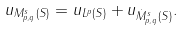Convert formula to latex. <formula><loc_0><loc_0><loc_500><loc_500>\| u \| _ { M ^ { s } _ { p , q } ( S ) } = \| u \| _ { L ^ { p } ( S ) } + \| u \| _ { \dot { M } ^ { s } _ { p , q } ( S ) } .</formula> 